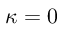<formula> <loc_0><loc_0><loc_500><loc_500>\kappa = 0</formula> 